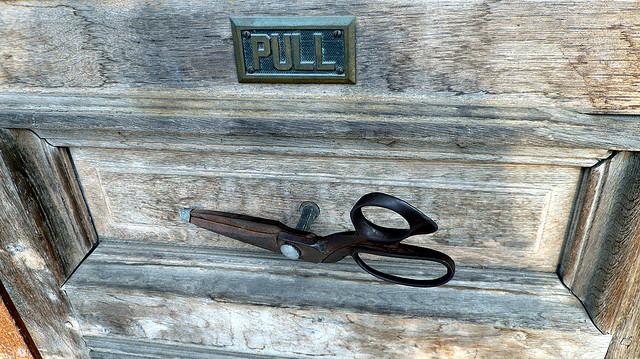What type of building is the door attached to?
Short answer required. Barber shop. How do you open the door?
Give a very brief answer. Pull. What is being used as a doorknob?
Be succinct. Scissors. 